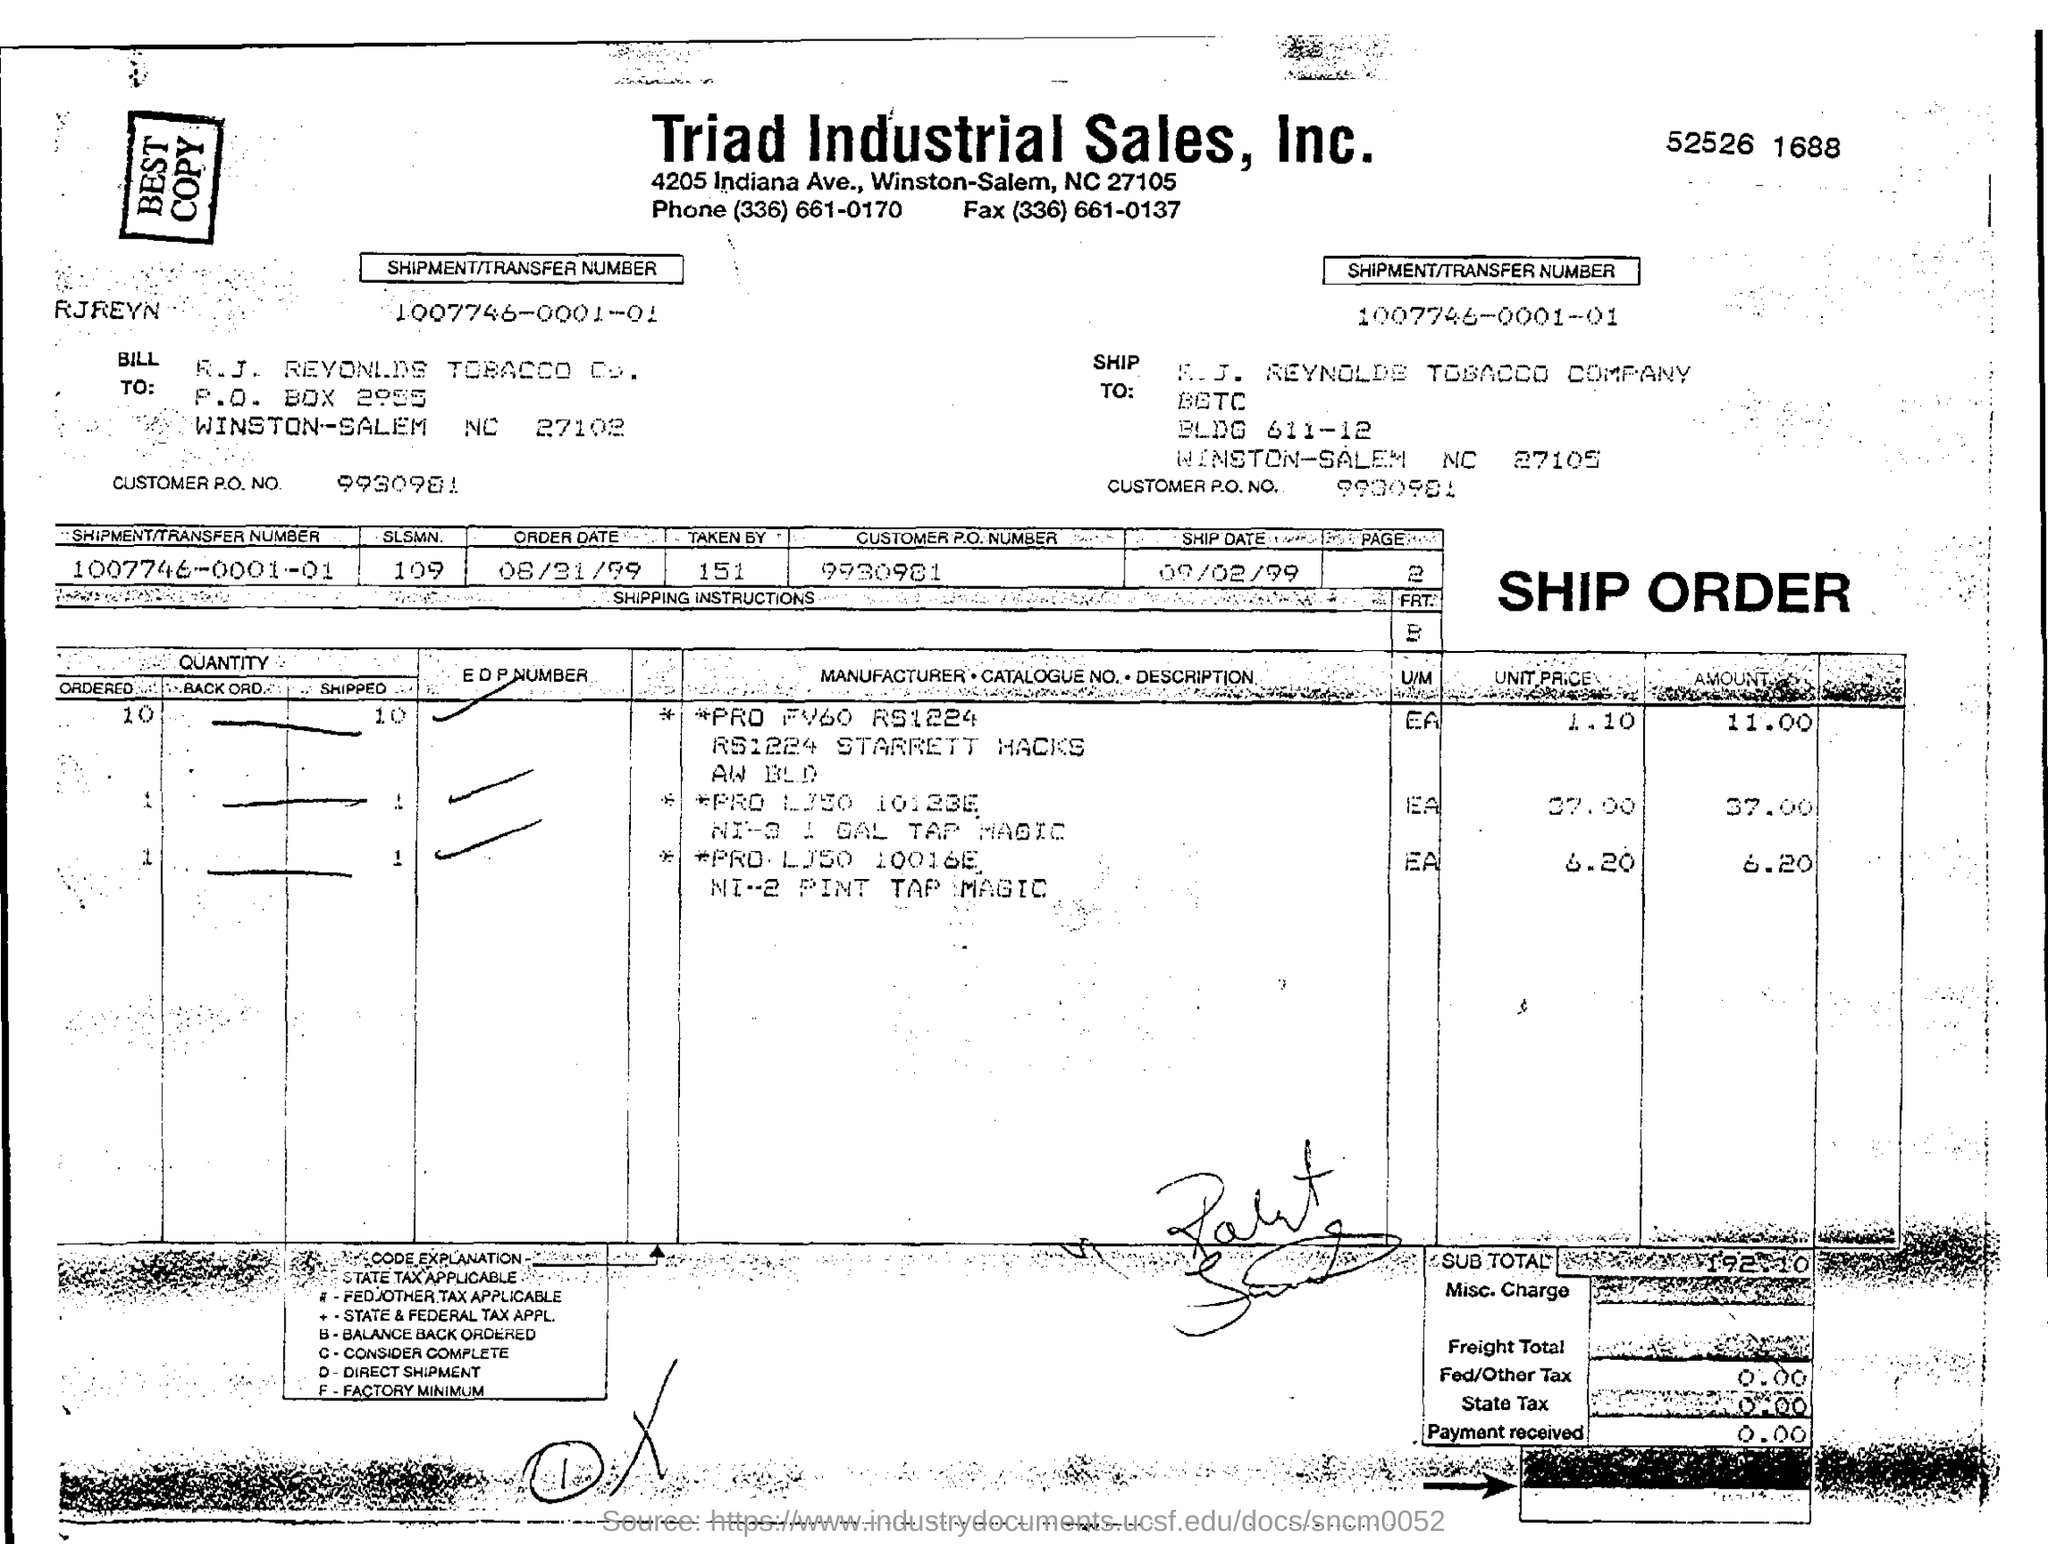TO WHICH COMPANY IT IS SHIPPED?
Your answer should be compact. R. J. Reynolds tobacco company. WHAT IS THE SHIPMENT/TRANSFER NUMBER?
Offer a terse response. 1007746-0001-01. WHAT IS THE SLSMN NUMBER?
Your response must be concise. 109. WHAT IS THE CUSTOMER P.O. NUMBER?
Make the answer very short. 9930981. WHAT IS THE SHIP DATE?
Offer a very short reply. 09/02/99. WHAT IS THE ORDER DATE?
Offer a terse response. 08/31/99. 